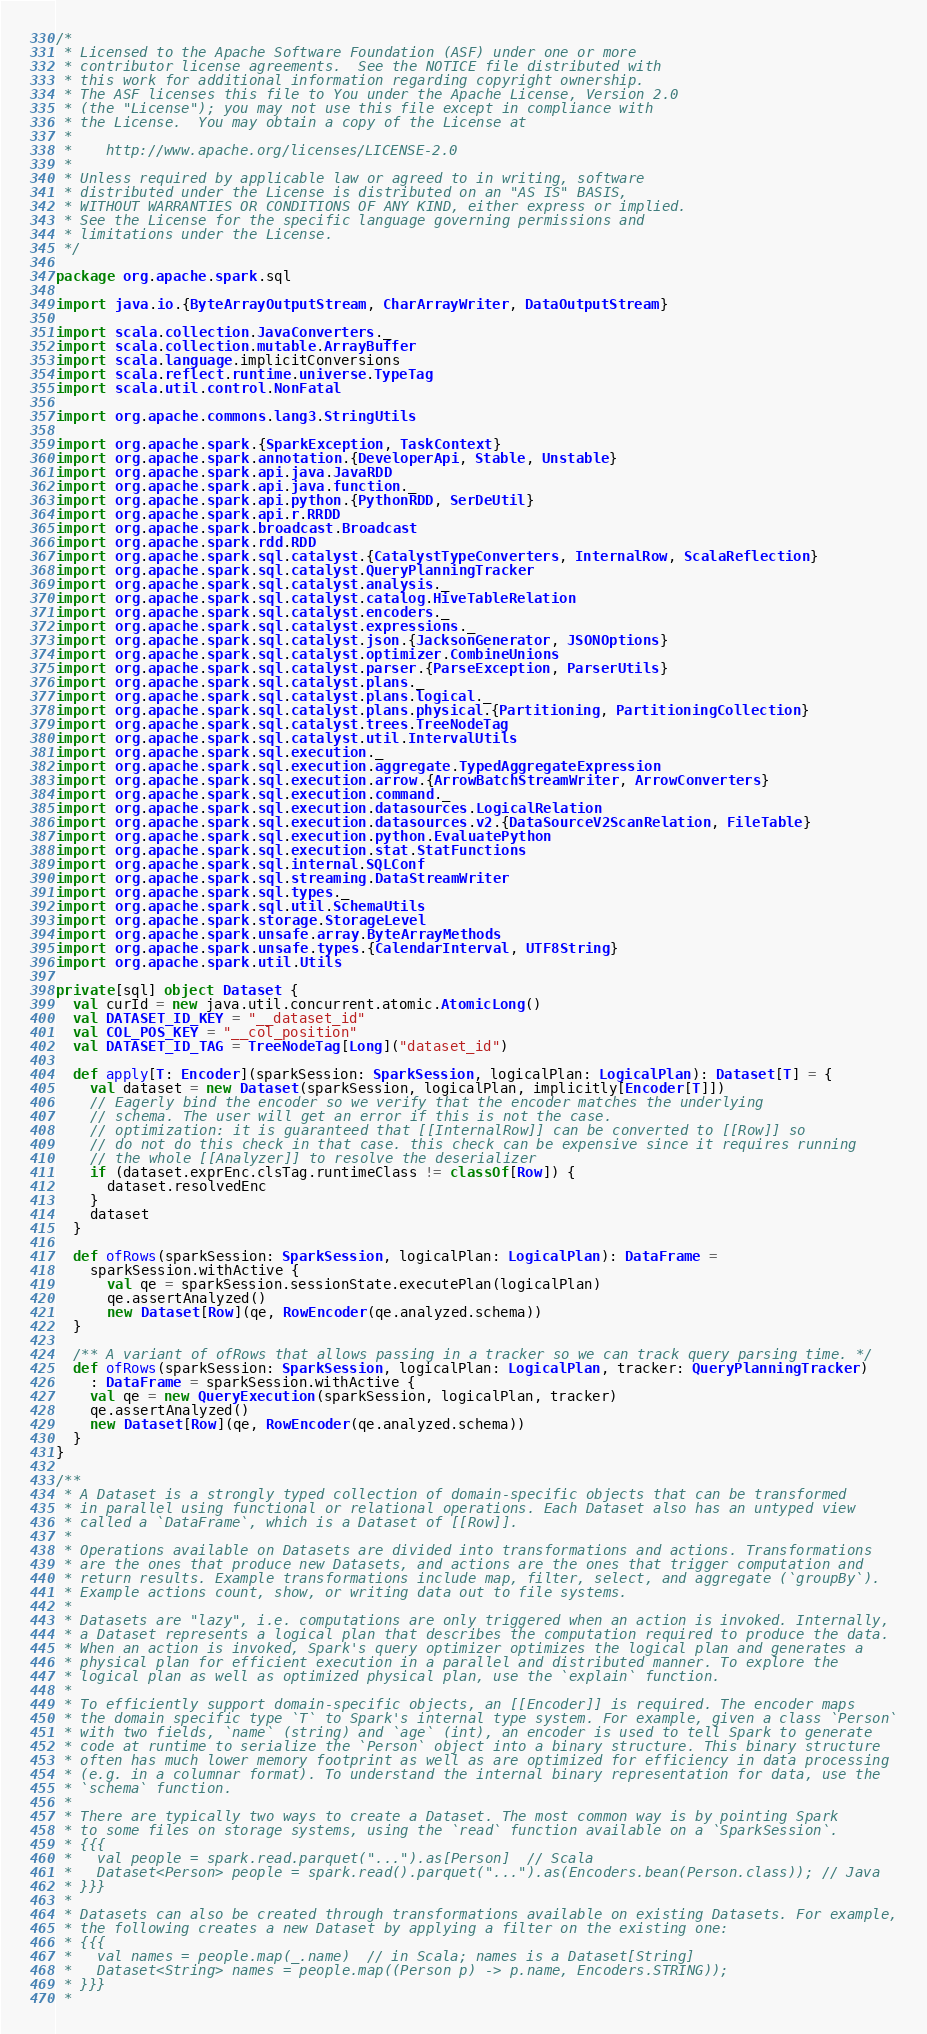<code> <loc_0><loc_0><loc_500><loc_500><_Scala_>/*
 * Licensed to the Apache Software Foundation (ASF) under one or more
 * contributor license agreements.  See the NOTICE file distributed with
 * this work for additional information regarding copyright ownership.
 * The ASF licenses this file to You under the Apache License, Version 2.0
 * (the "License"); you may not use this file except in compliance with
 * the License.  You may obtain a copy of the License at
 *
 *    http://www.apache.org/licenses/LICENSE-2.0
 *
 * Unless required by applicable law or agreed to in writing, software
 * distributed under the License is distributed on an "AS IS" BASIS,
 * WITHOUT WARRANTIES OR CONDITIONS OF ANY KIND, either express or implied.
 * See the License for the specific language governing permissions and
 * limitations under the License.
 */

package org.apache.spark.sql

import java.io.{ByteArrayOutputStream, CharArrayWriter, DataOutputStream}

import scala.collection.JavaConverters._
import scala.collection.mutable.ArrayBuffer
import scala.language.implicitConversions
import scala.reflect.runtime.universe.TypeTag
import scala.util.control.NonFatal

import org.apache.commons.lang3.StringUtils

import org.apache.spark.{SparkException, TaskContext}
import org.apache.spark.annotation.{DeveloperApi, Stable, Unstable}
import org.apache.spark.api.java.JavaRDD
import org.apache.spark.api.java.function._
import org.apache.spark.api.python.{PythonRDD, SerDeUtil}
import org.apache.spark.api.r.RRDD
import org.apache.spark.broadcast.Broadcast
import org.apache.spark.rdd.RDD
import org.apache.spark.sql.catalyst.{CatalystTypeConverters, InternalRow, ScalaReflection}
import org.apache.spark.sql.catalyst.QueryPlanningTracker
import org.apache.spark.sql.catalyst.analysis._
import org.apache.spark.sql.catalyst.catalog.HiveTableRelation
import org.apache.spark.sql.catalyst.encoders._
import org.apache.spark.sql.catalyst.expressions._
import org.apache.spark.sql.catalyst.json.{JacksonGenerator, JSONOptions}
import org.apache.spark.sql.catalyst.optimizer.CombineUnions
import org.apache.spark.sql.catalyst.parser.{ParseException, ParserUtils}
import org.apache.spark.sql.catalyst.plans._
import org.apache.spark.sql.catalyst.plans.logical._
import org.apache.spark.sql.catalyst.plans.physical.{Partitioning, PartitioningCollection}
import org.apache.spark.sql.catalyst.trees.TreeNodeTag
import org.apache.spark.sql.catalyst.util.IntervalUtils
import org.apache.spark.sql.execution._
import org.apache.spark.sql.execution.aggregate.TypedAggregateExpression
import org.apache.spark.sql.execution.arrow.{ArrowBatchStreamWriter, ArrowConverters}
import org.apache.spark.sql.execution.command._
import org.apache.spark.sql.execution.datasources.LogicalRelation
import org.apache.spark.sql.execution.datasources.v2.{DataSourceV2ScanRelation, FileTable}
import org.apache.spark.sql.execution.python.EvaluatePython
import org.apache.spark.sql.execution.stat.StatFunctions
import org.apache.spark.sql.internal.SQLConf
import org.apache.spark.sql.streaming.DataStreamWriter
import org.apache.spark.sql.types._
import org.apache.spark.sql.util.SchemaUtils
import org.apache.spark.storage.StorageLevel
import org.apache.spark.unsafe.array.ByteArrayMethods
import org.apache.spark.unsafe.types.{CalendarInterval, UTF8String}
import org.apache.spark.util.Utils

private[sql] object Dataset {
  val curId = new java.util.concurrent.atomic.AtomicLong()
  val DATASET_ID_KEY = "__dataset_id"
  val COL_POS_KEY = "__col_position"
  val DATASET_ID_TAG = TreeNodeTag[Long]("dataset_id")

  def apply[T: Encoder](sparkSession: SparkSession, logicalPlan: LogicalPlan): Dataset[T] = {
    val dataset = new Dataset(sparkSession, logicalPlan, implicitly[Encoder[T]])
    // Eagerly bind the encoder so we verify that the encoder matches the underlying
    // schema. The user will get an error if this is not the case.
    // optimization: it is guaranteed that [[InternalRow]] can be converted to [[Row]] so
    // do not do this check in that case. this check can be expensive since it requires running
    // the whole [[Analyzer]] to resolve the deserializer
    if (dataset.exprEnc.clsTag.runtimeClass != classOf[Row]) {
      dataset.resolvedEnc
    }
    dataset
  }

  def ofRows(sparkSession: SparkSession, logicalPlan: LogicalPlan): DataFrame =
    sparkSession.withActive {
      val qe = sparkSession.sessionState.executePlan(logicalPlan)
      qe.assertAnalyzed()
      new Dataset[Row](qe, RowEncoder(qe.analyzed.schema))
  }

  /** A variant of ofRows that allows passing in a tracker so we can track query parsing time. */
  def ofRows(sparkSession: SparkSession, logicalPlan: LogicalPlan, tracker: QueryPlanningTracker)
    : DataFrame = sparkSession.withActive {
    val qe = new QueryExecution(sparkSession, logicalPlan, tracker)
    qe.assertAnalyzed()
    new Dataset[Row](qe, RowEncoder(qe.analyzed.schema))
  }
}

/**
 * A Dataset is a strongly typed collection of domain-specific objects that can be transformed
 * in parallel using functional or relational operations. Each Dataset also has an untyped view
 * called a `DataFrame`, which is a Dataset of [[Row]].
 *
 * Operations available on Datasets are divided into transformations and actions. Transformations
 * are the ones that produce new Datasets, and actions are the ones that trigger computation and
 * return results. Example transformations include map, filter, select, and aggregate (`groupBy`).
 * Example actions count, show, or writing data out to file systems.
 *
 * Datasets are "lazy", i.e. computations are only triggered when an action is invoked. Internally,
 * a Dataset represents a logical plan that describes the computation required to produce the data.
 * When an action is invoked, Spark's query optimizer optimizes the logical plan and generates a
 * physical plan for efficient execution in a parallel and distributed manner. To explore the
 * logical plan as well as optimized physical plan, use the `explain` function.
 *
 * To efficiently support domain-specific objects, an [[Encoder]] is required. The encoder maps
 * the domain specific type `T` to Spark's internal type system. For example, given a class `Person`
 * with two fields, `name` (string) and `age` (int), an encoder is used to tell Spark to generate
 * code at runtime to serialize the `Person` object into a binary structure. This binary structure
 * often has much lower memory footprint as well as are optimized for efficiency in data processing
 * (e.g. in a columnar format). To understand the internal binary representation for data, use the
 * `schema` function.
 *
 * There are typically two ways to create a Dataset. The most common way is by pointing Spark
 * to some files on storage systems, using the `read` function available on a `SparkSession`.
 * {{{
 *   val people = spark.read.parquet("...").as[Person]  // Scala
 *   Dataset<Person> people = spark.read().parquet("...").as(Encoders.bean(Person.class)); // Java
 * }}}
 *
 * Datasets can also be created through transformations available on existing Datasets. For example,
 * the following creates a new Dataset by applying a filter on the existing one:
 * {{{
 *   val names = people.map(_.name)  // in Scala; names is a Dataset[String]
 *   Dataset<String> names = people.map((Person p) -> p.name, Encoders.STRING));
 * }}}
 *</code> 